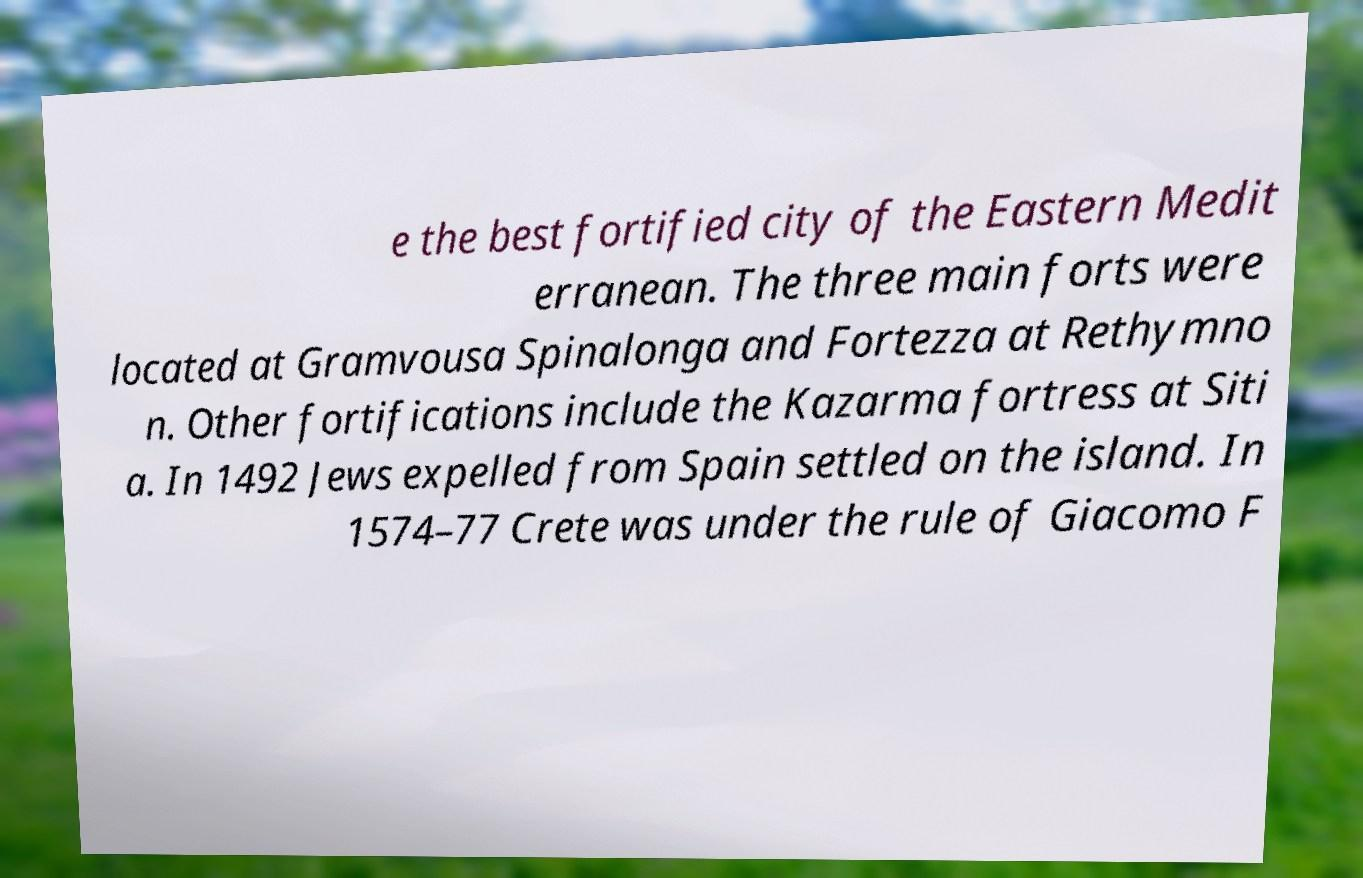Could you assist in decoding the text presented in this image and type it out clearly? e the best fortified city of the Eastern Medit erranean. The three main forts were located at Gramvousa Spinalonga and Fortezza at Rethymno n. Other fortifications include the Kazarma fortress at Siti a. In 1492 Jews expelled from Spain settled on the island. In 1574–77 Crete was under the rule of Giacomo F 